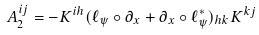<formula> <loc_0><loc_0><loc_500><loc_500>A _ { 2 } ^ { i j } = - K ^ { i h } ( \ell _ { \psi } \circ \partial _ { x } + \partial _ { x } \circ \ell _ { \psi } ^ { * } ) _ { h k } K ^ { k j }</formula> 